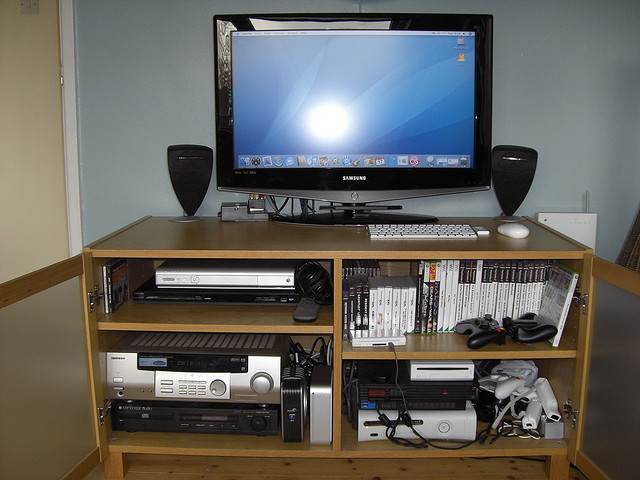Please transcribe the text in this image. 3 